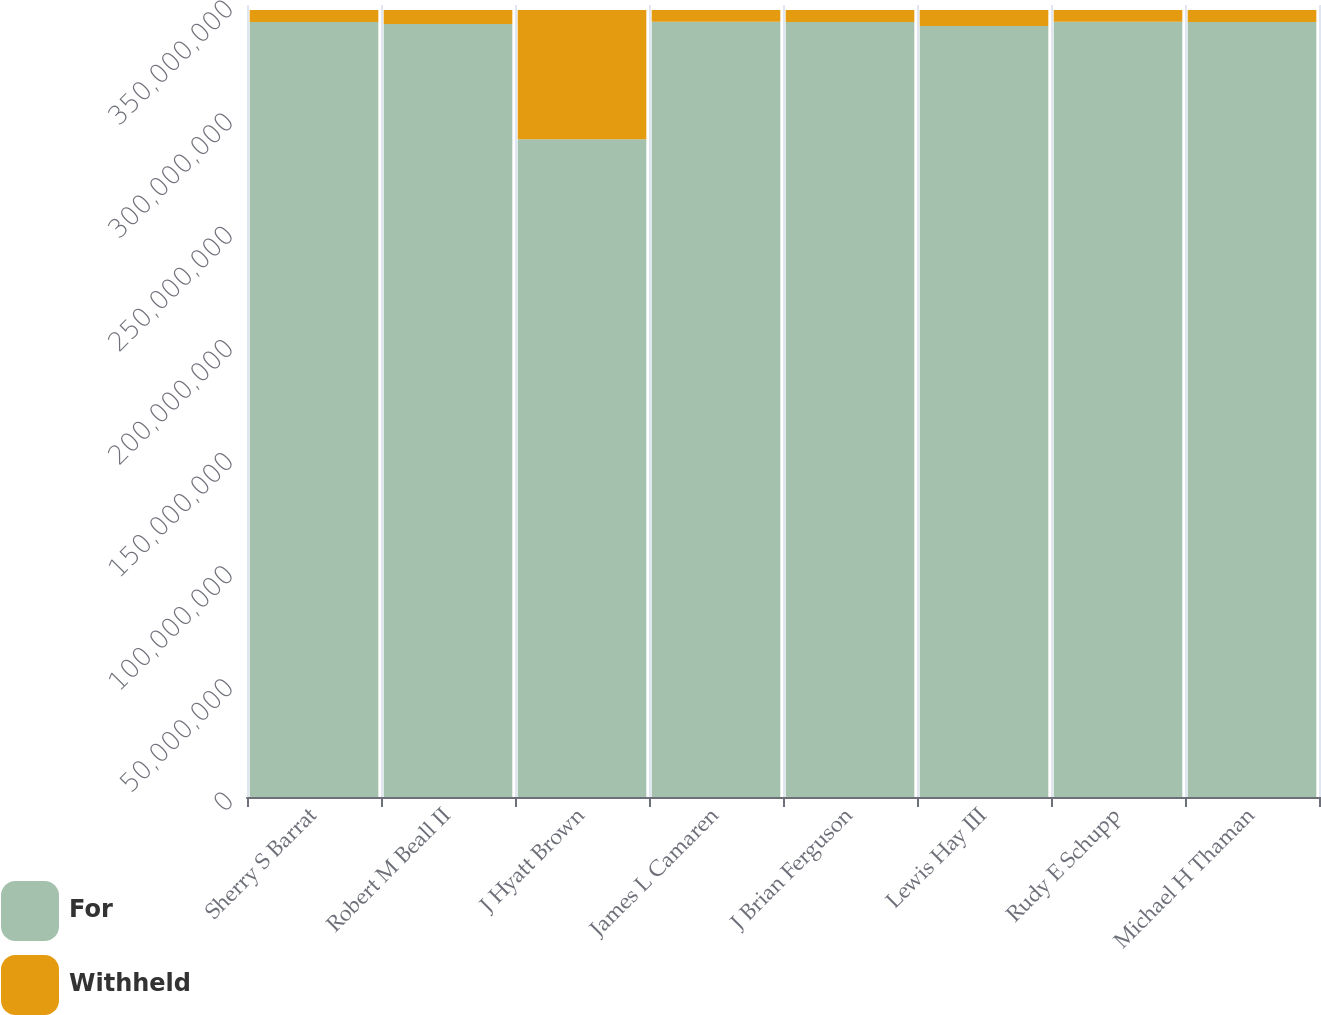<chart> <loc_0><loc_0><loc_500><loc_500><stacked_bar_chart><ecel><fcel>Sherry S Barrat<fcel>Robert M Beall II<fcel>J Hyatt Brown<fcel>James L Camaren<fcel>J Brian Ferguson<fcel>Lewis Hay III<fcel>Rudy E Schupp<fcel>Michael H Thaman<nl><fcel>For<fcel>3.4249e+08<fcel>3.41621e+08<fcel>2.90712e+08<fcel>3.42601e+08<fcel>3.42483e+08<fcel>3.40759e+08<fcel>3.42626e+08<fcel>3.42505e+08<nl><fcel>Withheld<fcel>5.32597e+06<fcel>6.19501e+06<fcel>5.71037e+07<fcel>5.21413e+06<fcel>5.33292e+06<fcel>7.05609e+06<fcel>5.18987e+06<fcel>5.31037e+06<nl></chart> 